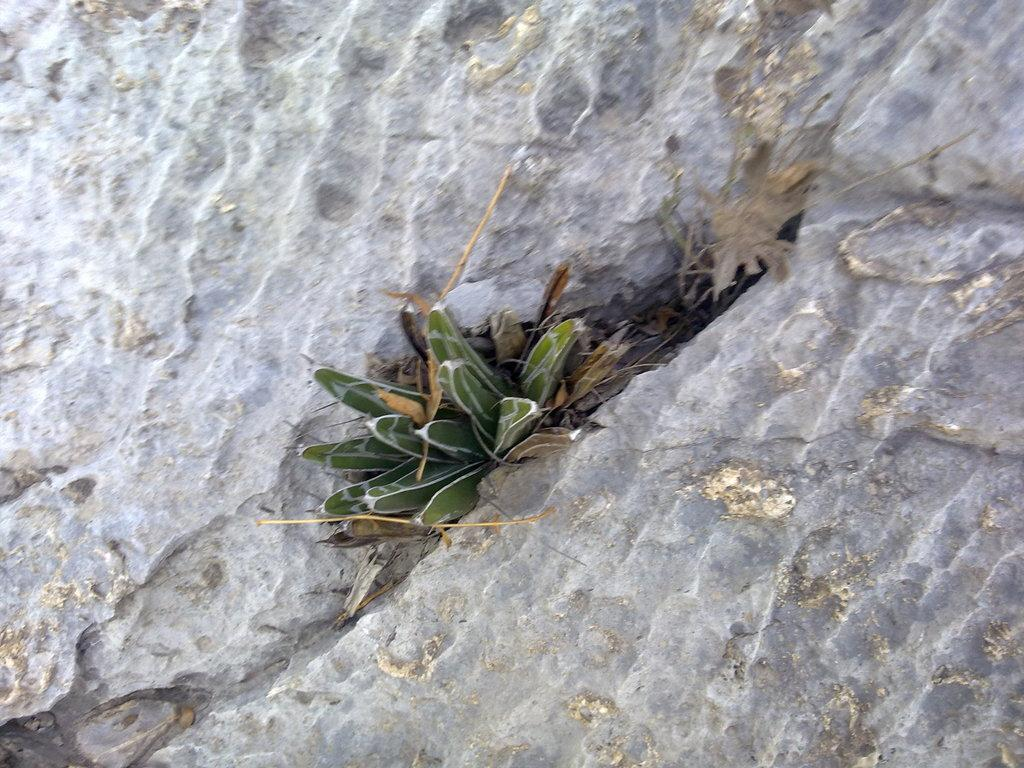What is the main subject of the image? The main subject of the image is a plant. Where is the plant located in the image? The plant is in the middle of a rock. What type of field can be seen in the background of the image? There is no field present in the image; it only features a plant in the middle of a rock. 